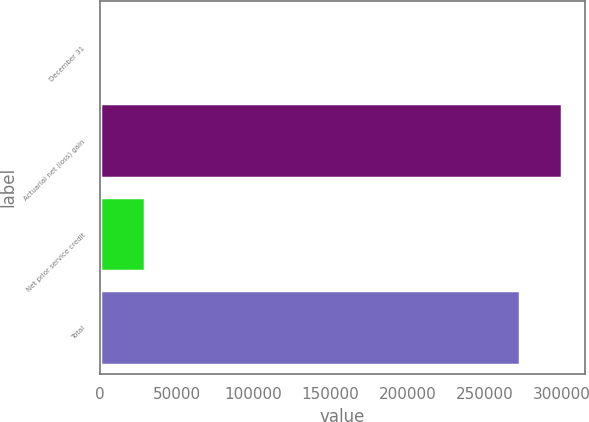Convert chart. <chart><loc_0><loc_0><loc_500><loc_500><bar_chart><fcel>December 31<fcel>Actuarial net (loss) gain<fcel>Net prior service credit<fcel>Total<nl><fcel>2009<fcel>300539<fcel>29476<fcel>273072<nl></chart> 